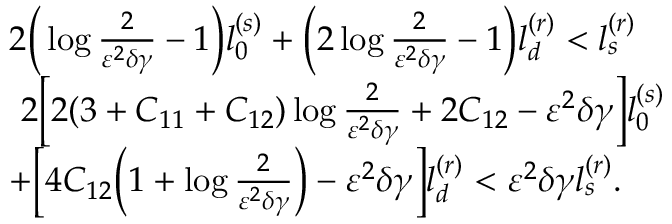Convert formula to latex. <formula><loc_0><loc_0><loc_500><loc_500>\begin{array} { r l } & { 2 \left ( \log \frac { 2 } { \varepsilon ^ { 2 } \delta \gamma } - 1 \right ) l _ { 0 } ^ { ( s ) } + \left ( 2 \log \frac { 2 } { \varepsilon ^ { 2 } \delta \gamma } - 1 \right ) l _ { d } ^ { ( r ) } < l _ { s } ^ { ( r ) } } \\ & { 2 \left [ 2 ( 3 + C _ { 1 1 } + C _ { 1 2 } ) \log \frac { 2 } { \varepsilon ^ { 2 } \delta \gamma } + 2 C _ { 1 2 } - \varepsilon ^ { 2 } \delta \gamma \right ] l _ { 0 } ^ { ( s ) } } \\ & { + \left [ 4 C _ { 1 2 } \left ( 1 + \log \frac { 2 } { \varepsilon ^ { 2 } \delta \gamma } \right ) - \varepsilon ^ { 2 } \delta \gamma \right ] l _ { d } ^ { ( r ) } < \varepsilon ^ { 2 } \delta \gamma l _ { s } ^ { ( r ) } . } \end{array}</formula> 